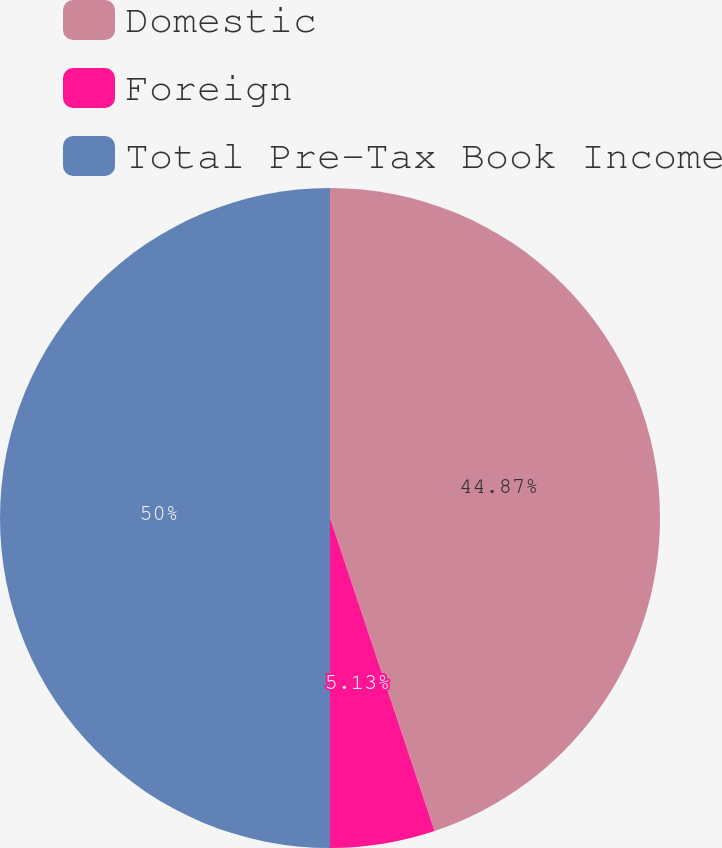Convert chart to OTSL. <chart><loc_0><loc_0><loc_500><loc_500><pie_chart><fcel>Domestic<fcel>Foreign<fcel>Total Pre-Tax Book Income<nl><fcel>44.87%<fcel>5.13%<fcel>50.0%<nl></chart> 